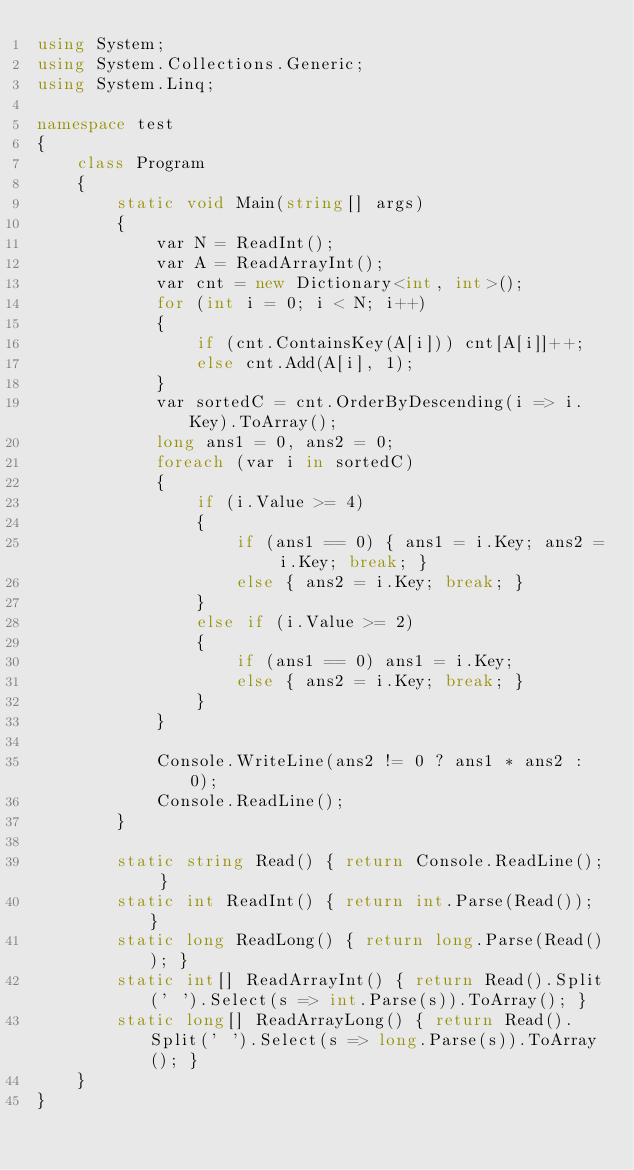<code> <loc_0><loc_0><loc_500><loc_500><_C#_>using System;
using System.Collections.Generic;
using System.Linq;

namespace test
{
    class Program
    {
        static void Main(string[] args)
        {
            var N = ReadInt();
            var A = ReadArrayInt();
            var cnt = new Dictionary<int, int>();
            for (int i = 0; i < N; i++)
            {
                if (cnt.ContainsKey(A[i])) cnt[A[i]]++;
                else cnt.Add(A[i], 1);
            }
            var sortedC = cnt.OrderByDescending(i => i.Key).ToArray();
            long ans1 = 0, ans2 = 0;
            foreach (var i in sortedC)
            {
                if (i.Value >= 4)
                {
                    if (ans1 == 0) { ans1 = i.Key; ans2 = i.Key; break; }
                    else { ans2 = i.Key; break; }
                }
                else if (i.Value >= 2)
                {
                    if (ans1 == 0) ans1 = i.Key;
                    else { ans2 = i.Key; break; }
                }
            }

            Console.WriteLine(ans2 != 0 ? ans1 * ans2 : 0);
            Console.ReadLine();
        }

        static string Read() { return Console.ReadLine(); }
        static int ReadInt() { return int.Parse(Read()); }
        static long ReadLong() { return long.Parse(Read()); }
        static int[] ReadArrayInt() { return Read().Split(' ').Select(s => int.Parse(s)).ToArray(); }
        static long[] ReadArrayLong() { return Read().Split(' ').Select(s => long.Parse(s)).ToArray(); }
    }
}</code> 